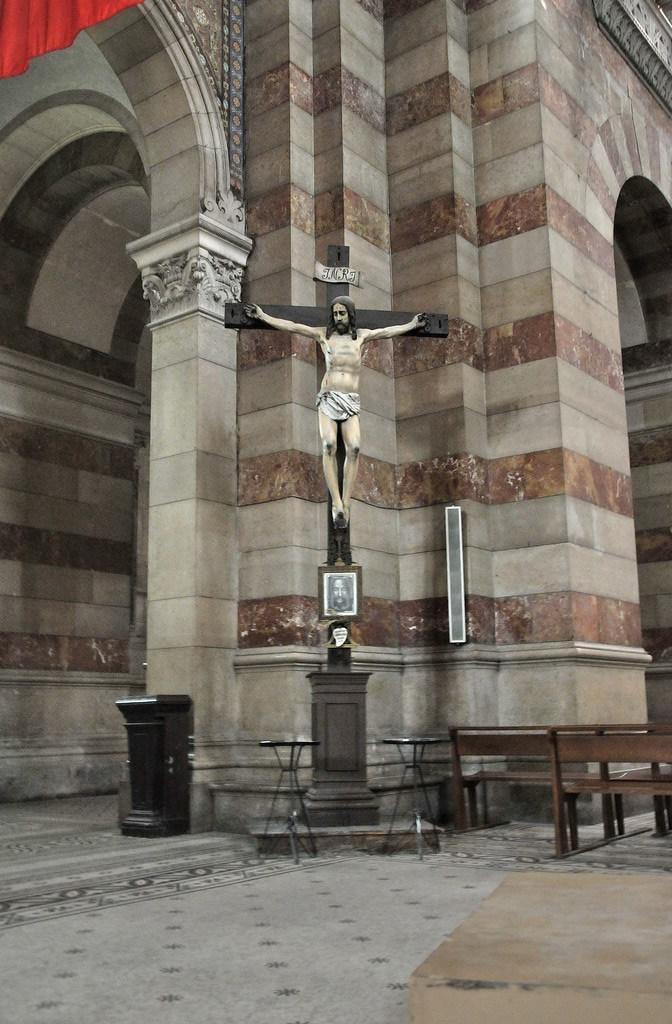Can you describe this image briefly? In the foreground of this image, there is a pavement and in the middle, there is a sculpture to the cross symbol and we can also see two tables, few benches and in the background, there is the building wall. 